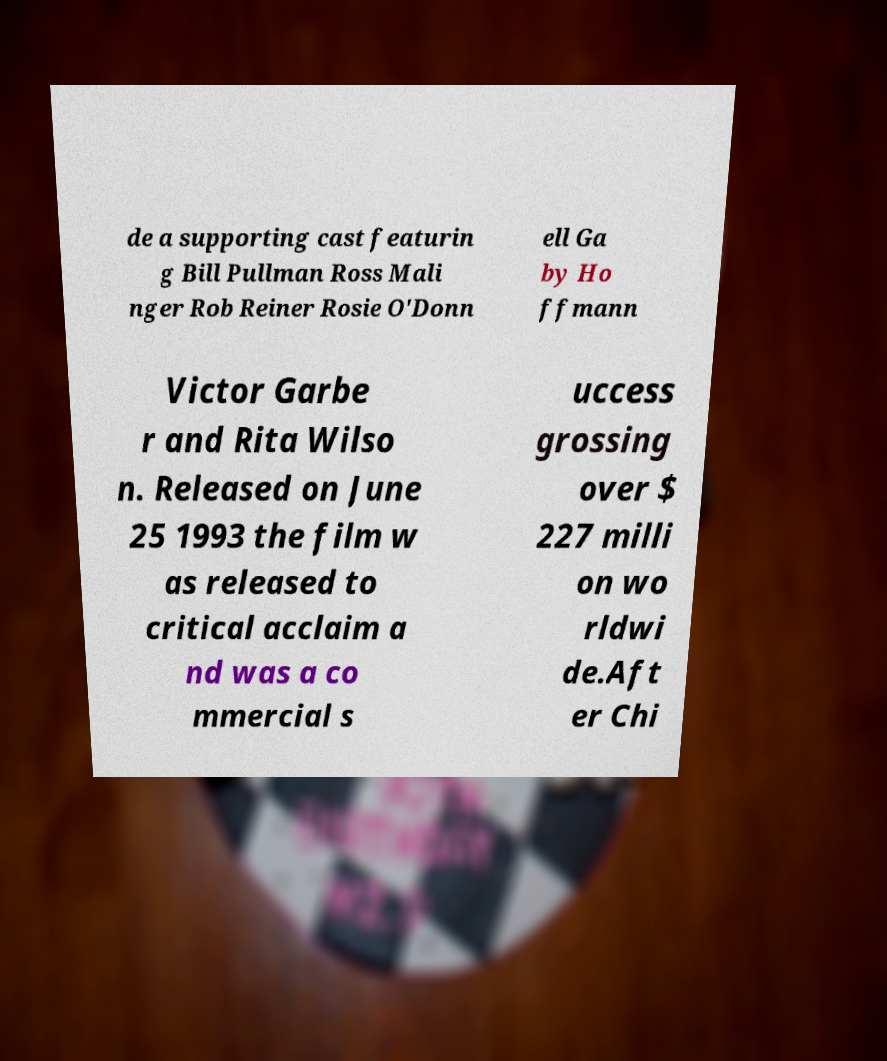Can you accurately transcribe the text from the provided image for me? de a supporting cast featurin g Bill Pullman Ross Mali nger Rob Reiner Rosie O'Donn ell Ga by Ho ffmann Victor Garbe r and Rita Wilso n. Released on June 25 1993 the film w as released to critical acclaim a nd was a co mmercial s uccess grossing over $ 227 milli on wo rldwi de.Aft er Chi 